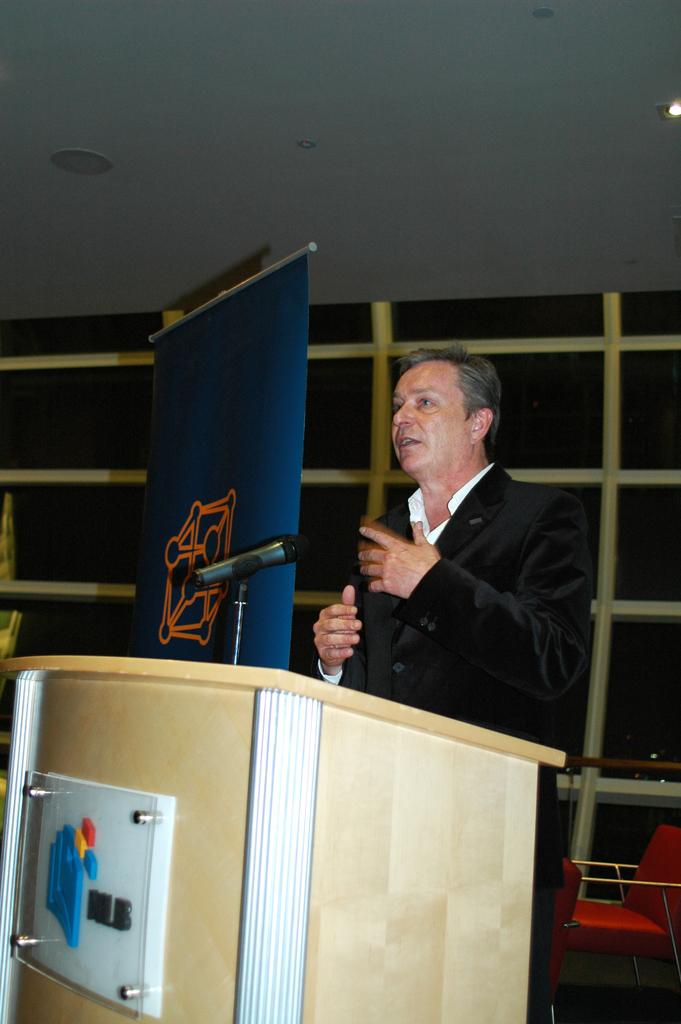What is the man near in the image? The man is standing near the podium in the image. What device is present for amplifying the man's voice? There is a microphone (mike) in the image. What can be seen hanging or displayed in the image? There is a banner in the image. What type of furniture is visible in the image? There are chairs in the image. What is visible in the background of the image? There is a wall in the background of the image. How many balloons are tied to the tree in the image? There is no tree or balloons present in the image. Are the man's brothers sitting in the chairs in the image? There is no information about the man's brothers in the image, and no one's identity is specified in relation to the chairs. 